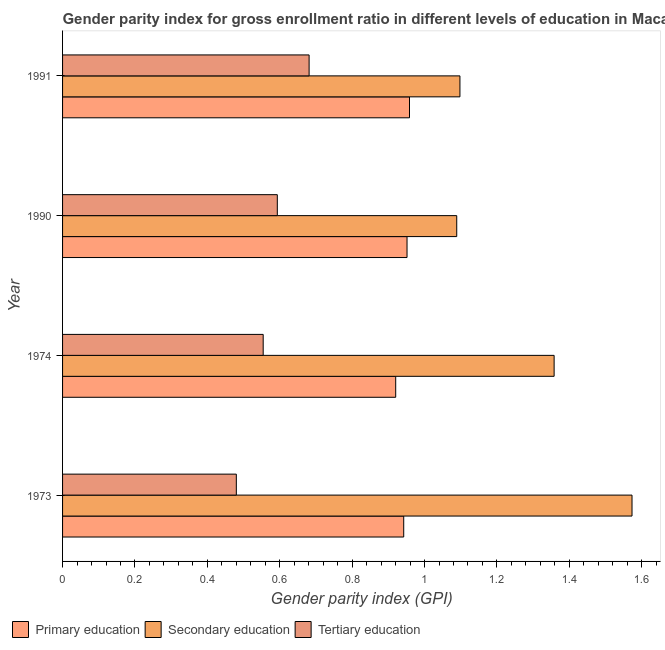How many different coloured bars are there?
Offer a very short reply. 3. How many groups of bars are there?
Offer a terse response. 4. How many bars are there on the 1st tick from the bottom?
Keep it short and to the point. 3. What is the label of the 3rd group of bars from the top?
Make the answer very short. 1974. What is the gender parity index in primary education in 1973?
Make the answer very short. 0.94. Across all years, what is the maximum gender parity index in tertiary education?
Keep it short and to the point. 0.68. Across all years, what is the minimum gender parity index in primary education?
Give a very brief answer. 0.92. In which year was the gender parity index in secondary education maximum?
Offer a terse response. 1973. In which year was the gender parity index in secondary education minimum?
Give a very brief answer. 1990. What is the total gender parity index in tertiary education in the graph?
Keep it short and to the point. 2.31. What is the difference between the gender parity index in primary education in 1990 and that in 1991?
Offer a terse response. -0.01. What is the difference between the gender parity index in primary education in 1974 and the gender parity index in secondary education in 1990?
Provide a short and direct response. -0.17. What is the average gender parity index in secondary education per year?
Your answer should be very brief. 1.28. In the year 1973, what is the difference between the gender parity index in primary education and gender parity index in tertiary education?
Your answer should be compact. 0.46. In how many years, is the gender parity index in primary education greater than 0.8400000000000001 ?
Provide a short and direct response. 4. What is the ratio of the gender parity index in primary education in 1973 to that in 1974?
Provide a succinct answer. 1.02. Is the gender parity index in secondary education in 1973 less than that in 1991?
Offer a very short reply. No. What is the difference between the highest and the second highest gender parity index in primary education?
Give a very brief answer. 0.01. What is the difference between the highest and the lowest gender parity index in secondary education?
Provide a succinct answer. 0.48. What does the 2nd bar from the top in 1990 represents?
Your answer should be very brief. Secondary education. Is it the case that in every year, the sum of the gender parity index in primary education and gender parity index in secondary education is greater than the gender parity index in tertiary education?
Your answer should be very brief. Yes. What is the difference between two consecutive major ticks on the X-axis?
Provide a succinct answer. 0.2. Are the values on the major ticks of X-axis written in scientific E-notation?
Your response must be concise. No. Does the graph contain any zero values?
Your answer should be compact. No. How many legend labels are there?
Offer a very short reply. 3. How are the legend labels stacked?
Your answer should be very brief. Horizontal. What is the title of the graph?
Offer a very short reply. Gender parity index for gross enrollment ratio in different levels of education in Macao. What is the label or title of the X-axis?
Your answer should be very brief. Gender parity index (GPI). What is the Gender parity index (GPI) in Primary education in 1973?
Your answer should be very brief. 0.94. What is the Gender parity index (GPI) in Secondary education in 1973?
Your answer should be compact. 1.57. What is the Gender parity index (GPI) in Tertiary education in 1973?
Keep it short and to the point. 0.48. What is the Gender parity index (GPI) in Primary education in 1974?
Offer a terse response. 0.92. What is the Gender parity index (GPI) of Secondary education in 1974?
Offer a very short reply. 1.36. What is the Gender parity index (GPI) of Tertiary education in 1974?
Give a very brief answer. 0.55. What is the Gender parity index (GPI) in Primary education in 1990?
Make the answer very short. 0.95. What is the Gender parity index (GPI) of Secondary education in 1990?
Give a very brief answer. 1.09. What is the Gender parity index (GPI) of Tertiary education in 1990?
Keep it short and to the point. 0.59. What is the Gender parity index (GPI) in Primary education in 1991?
Keep it short and to the point. 0.96. What is the Gender parity index (GPI) of Secondary education in 1991?
Make the answer very short. 1.1. What is the Gender parity index (GPI) in Tertiary education in 1991?
Your answer should be compact. 0.68. Across all years, what is the maximum Gender parity index (GPI) of Primary education?
Provide a short and direct response. 0.96. Across all years, what is the maximum Gender parity index (GPI) in Secondary education?
Provide a short and direct response. 1.57. Across all years, what is the maximum Gender parity index (GPI) in Tertiary education?
Give a very brief answer. 0.68. Across all years, what is the minimum Gender parity index (GPI) in Primary education?
Make the answer very short. 0.92. Across all years, what is the minimum Gender parity index (GPI) in Secondary education?
Your response must be concise. 1.09. Across all years, what is the minimum Gender parity index (GPI) in Tertiary education?
Make the answer very short. 0.48. What is the total Gender parity index (GPI) in Primary education in the graph?
Give a very brief answer. 3.77. What is the total Gender parity index (GPI) of Secondary education in the graph?
Give a very brief answer. 5.12. What is the total Gender parity index (GPI) in Tertiary education in the graph?
Provide a succinct answer. 2.31. What is the difference between the Gender parity index (GPI) in Primary education in 1973 and that in 1974?
Offer a very short reply. 0.02. What is the difference between the Gender parity index (GPI) in Secondary education in 1973 and that in 1974?
Your answer should be very brief. 0.22. What is the difference between the Gender parity index (GPI) of Tertiary education in 1973 and that in 1974?
Ensure brevity in your answer.  -0.07. What is the difference between the Gender parity index (GPI) in Primary education in 1973 and that in 1990?
Offer a terse response. -0.01. What is the difference between the Gender parity index (GPI) in Secondary education in 1973 and that in 1990?
Offer a terse response. 0.48. What is the difference between the Gender parity index (GPI) of Tertiary education in 1973 and that in 1990?
Offer a very short reply. -0.11. What is the difference between the Gender parity index (GPI) in Primary education in 1973 and that in 1991?
Ensure brevity in your answer.  -0.02. What is the difference between the Gender parity index (GPI) of Secondary education in 1973 and that in 1991?
Ensure brevity in your answer.  0.48. What is the difference between the Gender parity index (GPI) of Tertiary education in 1973 and that in 1991?
Offer a very short reply. -0.2. What is the difference between the Gender parity index (GPI) in Primary education in 1974 and that in 1990?
Your answer should be very brief. -0.03. What is the difference between the Gender parity index (GPI) in Secondary education in 1974 and that in 1990?
Offer a very short reply. 0.27. What is the difference between the Gender parity index (GPI) of Tertiary education in 1974 and that in 1990?
Provide a succinct answer. -0.04. What is the difference between the Gender parity index (GPI) of Primary education in 1974 and that in 1991?
Ensure brevity in your answer.  -0.04. What is the difference between the Gender parity index (GPI) in Secondary education in 1974 and that in 1991?
Your response must be concise. 0.26. What is the difference between the Gender parity index (GPI) of Tertiary education in 1974 and that in 1991?
Provide a short and direct response. -0.13. What is the difference between the Gender parity index (GPI) in Primary education in 1990 and that in 1991?
Your answer should be compact. -0.01. What is the difference between the Gender parity index (GPI) of Secondary education in 1990 and that in 1991?
Keep it short and to the point. -0.01. What is the difference between the Gender parity index (GPI) of Tertiary education in 1990 and that in 1991?
Your answer should be compact. -0.09. What is the difference between the Gender parity index (GPI) of Primary education in 1973 and the Gender parity index (GPI) of Secondary education in 1974?
Provide a succinct answer. -0.42. What is the difference between the Gender parity index (GPI) in Primary education in 1973 and the Gender parity index (GPI) in Tertiary education in 1974?
Keep it short and to the point. 0.39. What is the difference between the Gender parity index (GPI) in Secondary education in 1973 and the Gender parity index (GPI) in Tertiary education in 1974?
Your response must be concise. 1.02. What is the difference between the Gender parity index (GPI) of Primary education in 1973 and the Gender parity index (GPI) of Secondary education in 1990?
Give a very brief answer. -0.15. What is the difference between the Gender parity index (GPI) in Primary education in 1973 and the Gender parity index (GPI) in Tertiary education in 1990?
Keep it short and to the point. 0.35. What is the difference between the Gender parity index (GPI) in Secondary education in 1973 and the Gender parity index (GPI) in Tertiary education in 1990?
Provide a short and direct response. 0.98. What is the difference between the Gender parity index (GPI) of Primary education in 1973 and the Gender parity index (GPI) of Secondary education in 1991?
Ensure brevity in your answer.  -0.16. What is the difference between the Gender parity index (GPI) in Primary education in 1973 and the Gender parity index (GPI) in Tertiary education in 1991?
Provide a succinct answer. 0.26. What is the difference between the Gender parity index (GPI) of Secondary education in 1973 and the Gender parity index (GPI) of Tertiary education in 1991?
Your answer should be compact. 0.89. What is the difference between the Gender parity index (GPI) of Primary education in 1974 and the Gender parity index (GPI) of Secondary education in 1990?
Provide a short and direct response. -0.17. What is the difference between the Gender parity index (GPI) in Primary education in 1974 and the Gender parity index (GPI) in Tertiary education in 1990?
Ensure brevity in your answer.  0.33. What is the difference between the Gender parity index (GPI) in Secondary education in 1974 and the Gender parity index (GPI) in Tertiary education in 1990?
Provide a succinct answer. 0.76. What is the difference between the Gender parity index (GPI) of Primary education in 1974 and the Gender parity index (GPI) of Secondary education in 1991?
Make the answer very short. -0.18. What is the difference between the Gender parity index (GPI) of Primary education in 1974 and the Gender parity index (GPI) of Tertiary education in 1991?
Give a very brief answer. 0.24. What is the difference between the Gender parity index (GPI) in Secondary education in 1974 and the Gender parity index (GPI) in Tertiary education in 1991?
Your answer should be very brief. 0.68. What is the difference between the Gender parity index (GPI) of Primary education in 1990 and the Gender parity index (GPI) of Secondary education in 1991?
Your answer should be compact. -0.15. What is the difference between the Gender parity index (GPI) of Primary education in 1990 and the Gender parity index (GPI) of Tertiary education in 1991?
Give a very brief answer. 0.27. What is the difference between the Gender parity index (GPI) in Secondary education in 1990 and the Gender parity index (GPI) in Tertiary education in 1991?
Your answer should be compact. 0.41. What is the average Gender parity index (GPI) of Primary education per year?
Offer a very short reply. 0.94. What is the average Gender parity index (GPI) in Secondary education per year?
Your answer should be compact. 1.28. What is the average Gender parity index (GPI) in Tertiary education per year?
Your answer should be very brief. 0.58. In the year 1973, what is the difference between the Gender parity index (GPI) in Primary education and Gender parity index (GPI) in Secondary education?
Provide a short and direct response. -0.63. In the year 1973, what is the difference between the Gender parity index (GPI) of Primary education and Gender parity index (GPI) of Tertiary education?
Give a very brief answer. 0.46. In the year 1973, what is the difference between the Gender parity index (GPI) in Secondary education and Gender parity index (GPI) in Tertiary education?
Make the answer very short. 1.09. In the year 1974, what is the difference between the Gender parity index (GPI) in Primary education and Gender parity index (GPI) in Secondary education?
Your answer should be very brief. -0.44. In the year 1974, what is the difference between the Gender parity index (GPI) in Primary education and Gender parity index (GPI) in Tertiary education?
Keep it short and to the point. 0.37. In the year 1974, what is the difference between the Gender parity index (GPI) in Secondary education and Gender parity index (GPI) in Tertiary education?
Your response must be concise. 0.8. In the year 1990, what is the difference between the Gender parity index (GPI) of Primary education and Gender parity index (GPI) of Secondary education?
Your answer should be compact. -0.14. In the year 1990, what is the difference between the Gender parity index (GPI) of Primary education and Gender parity index (GPI) of Tertiary education?
Offer a terse response. 0.36. In the year 1990, what is the difference between the Gender parity index (GPI) of Secondary education and Gender parity index (GPI) of Tertiary education?
Give a very brief answer. 0.5. In the year 1991, what is the difference between the Gender parity index (GPI) in Primary education and Gender parity index (GPI) in Secondary education?
Provide a succinct answer. -0.14. In the year 1991, what is the difference between the Gender parity index (GPI) in Primary education and Gender parity index (GPI) in Tertiary education?
Offer a terse response. 0.28. In the year 1991, what is the difference between the Gender parity index (GPI) in Secondary education and Gender parity index (GPI) in Tertiary education?
Your response must be concise. 0.42. What is the ratio of the Gender parity index (GPI) in Secondary education in 1973 to that in 1974?
Your answer should be compact. 1.16. What is the ratio of the Gender parity index (GPI) of Tertiary education in 1973 to that in 1974?
Give a very brief answer. 0.87. What is the ratio of the Gender parity index (GPI) of Secondary education in 1973 to that in 1990?
Keep it short and to the point. 1.44. What is the ratio of the Gender parity index (GPI) in Tertiary education in 1973 to that in 1990?
Offer a very short reply. 0.81. What is the ratio of the Gender parity index (GPI) of Primary education in 1973 to that in 1991?
Provide a succinct answer. 0.98. What is the ratio of the Gender parity index (GPI) of Secondary education in 1973 to that in 1991?
Ensure brevity in your answer.  1.43. What is the ratio of the Gender parity index (GPI) in Tertiary education in 1973 to that in 1991?
Give a very brief answer. 0.7. What is the ratio of the Gender parity index (GPI) of Primary education in 1974 to that in 1990?
Give a very brief answer. 0.97. What is the ratio of the Gender parity index (GPI) of Secondary education in 1974 to that in 1990?
Provide a short and direct response. 1.25. What is the ratio of the Gender parity index (GPI) in Tertiary education in 1974 to that in 1990?
Provide a short and direct response. 0.93. What is the ratio of the Gender parity index (GPI) of Primary education in 1974 to that in 1991?
Ensure brevity in your answer.  0.96. What is the ratio of the Gender parity index (GPI) of Secondary education in 1974 to that in 1991?
Keep it short and to the point. 1.24. What is the ratio of the Gender parity index (GPI) in Tertiary education in 1974 to that in 1991?
Keep it short and to the point. 0.81. What is the ratio of the Gender parity index (GPI) of Tertiary education in 1990 to that in 1991?
Provide a succinct answer. 0.87. What is the difference between the highest and the second highest Gender parity index (GPI) in Primary education?
Offer a very short reply. 0.01. What is the difference between the highest and the second highest Gender parity index (GPI) in Secondary education?
Keep it short and to the point. 0.22. What is the difference between the highest and the second highest Gender parity index (GPI) in Tertiary education?
Your answer should be compact. 0.09. What is the difference between the highest and the lowest Gender parity index (GPI) of Primary education?
Offer a very short reply. 0.04. What is the difference between the highest and the lowest Gender parity index (GPI) in Secondary education?
Your answer should be compact. 0.48. What is the difference between the highest and the lowest Gender parity index (GPI) of Tertiary education?
Your response must be concise. 0.2. 